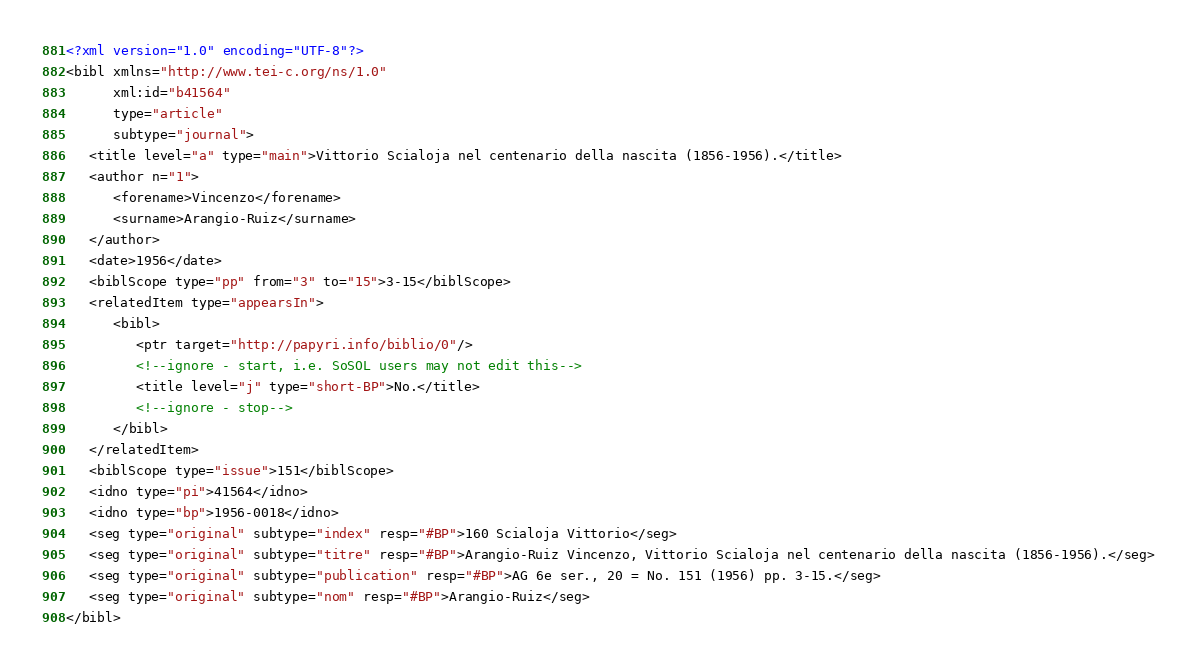<code> <loc_0><loc_0><loc_500><loc_500><_XML_><?xml version="1.0" encoding="UTF-8"?>
<bibl xmlns="http://www.tei-c.org/ns/1.0"
      xml:id="b41564"
      type="article"
      subtype="journal">
   <title level="a" type="main">Vittorio Scialoja nel centenario della nascita (1856-1956).</title>
   <author n="1">
      <forename>Vincenzo</forename>
      <surname>Arangio-Ruiz</surname>
   </author>
   <date>1956</date>
   <biblScope type="pp" from="3" to="15">3-15</biblScope>
   <relatedItem type="appearsIn">
      <bibl>
         <ptr target="http://papyri.info/biblio/0"/>
         <!--ignore - start, i.e. SoSOL users may not edit this-->
         <title level="j" type="short-BP">No.</title>
         <!--ignore - stop-->
      </bibl>
   </relatedItem>
   <biblScope type="issue">151</biblScope>
   <idno type="pi">41564</idno>
   <idno type="bp">1956-0018</idno>
   <seg type="original" subtype="index" resp="#BP">160 Scialoja Vittorio</seg>
   <seg type="original" subtype="titre" resp="#BP">Arangio-Ruiz Vincenzo, Vittorio Scialoja nel centenario della nascita (1856-1956).</seg>
   <seg type="original" subtype="publication" resp="#BP">AG 6e ser., 20 = No. 151 (1956) pp. 3-15.</seg>
   <seg type="original" subtype="nom" resp="#BP">Arangio-Ruiz</seg>
</bibl>
</code> 